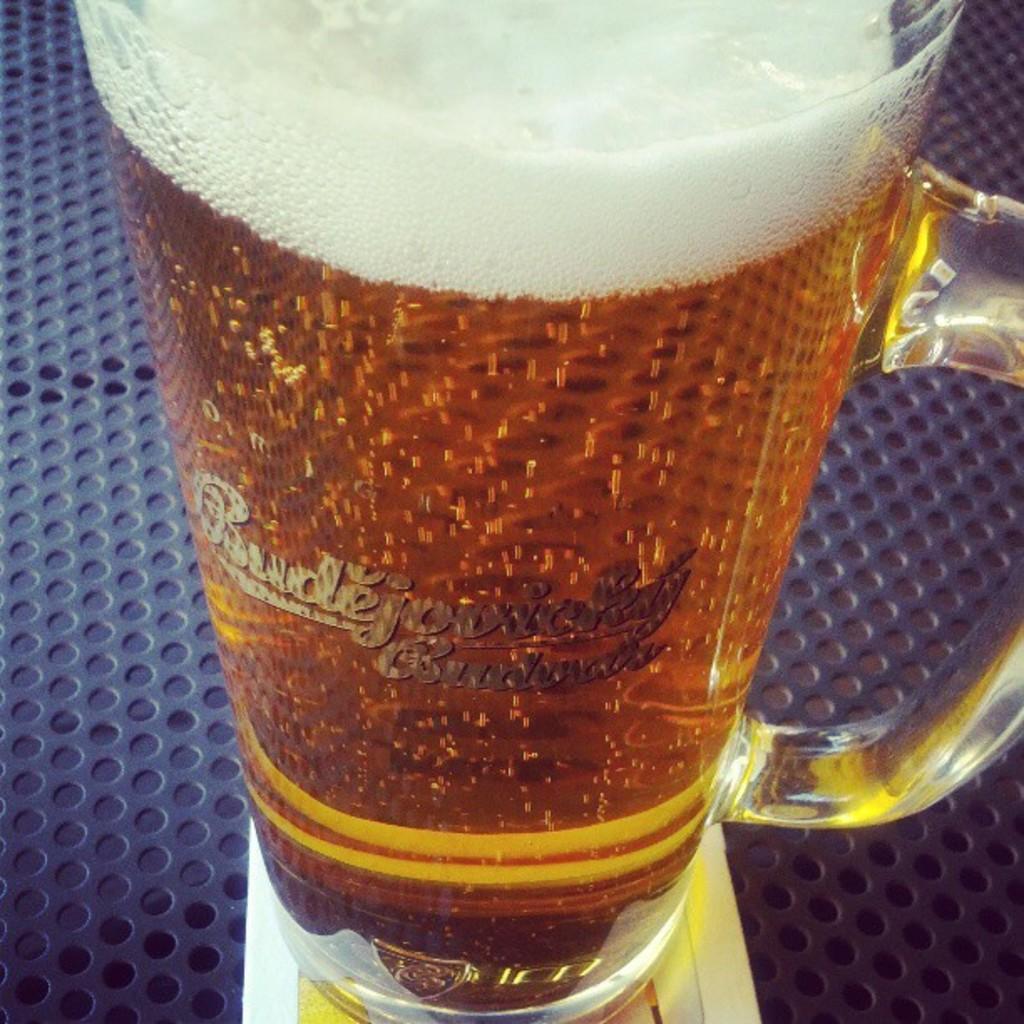How would you summarize this image in a sentence or two? In this image, we can see a glass with some liquid is placed on an object. We can also see a white colored object. 